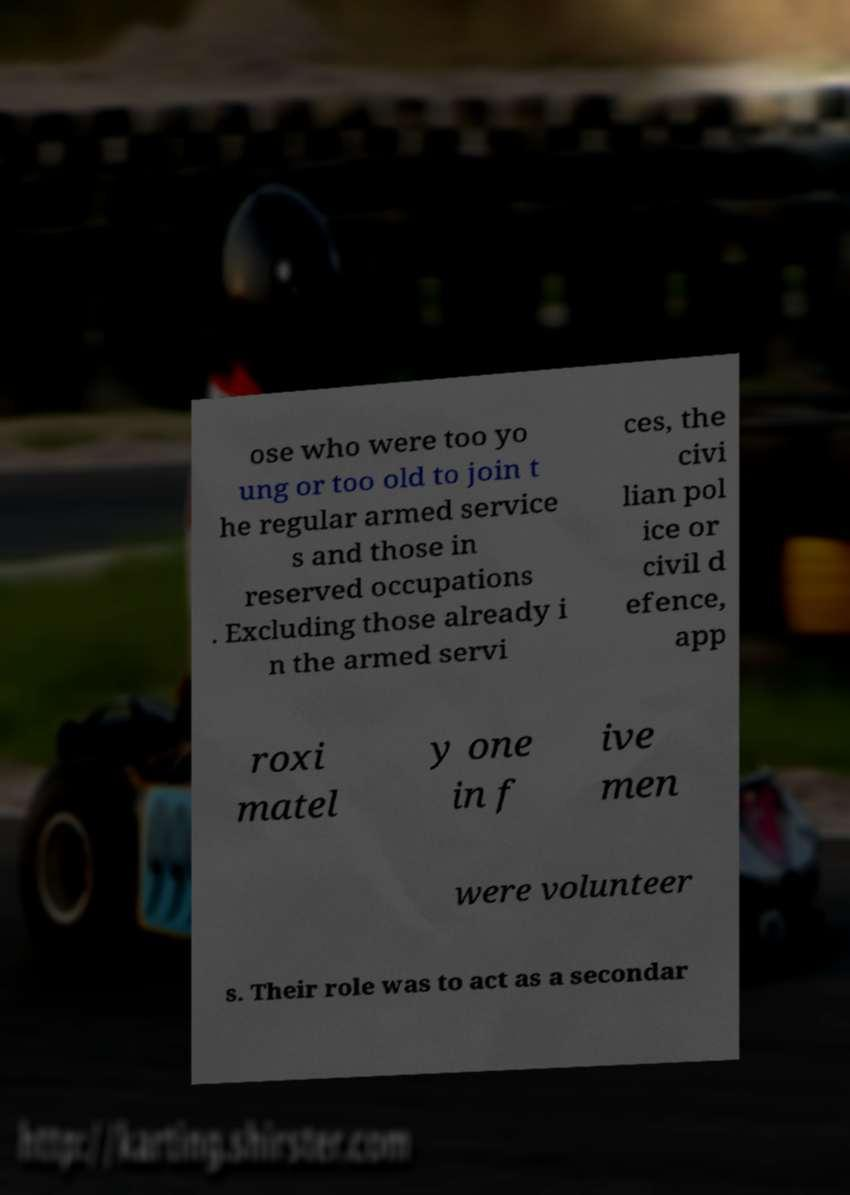I need the written content from this picture converted into text. Can you do that? ose who were too yo ung or too old to join t he regular armed service s and those in reserved occupations . Excluding those already i n the armed servi ces, the civi lian pol ice or civil d efence, app roxi matel y one in f ive men were volunteer s. Their role was to act as a secondar 